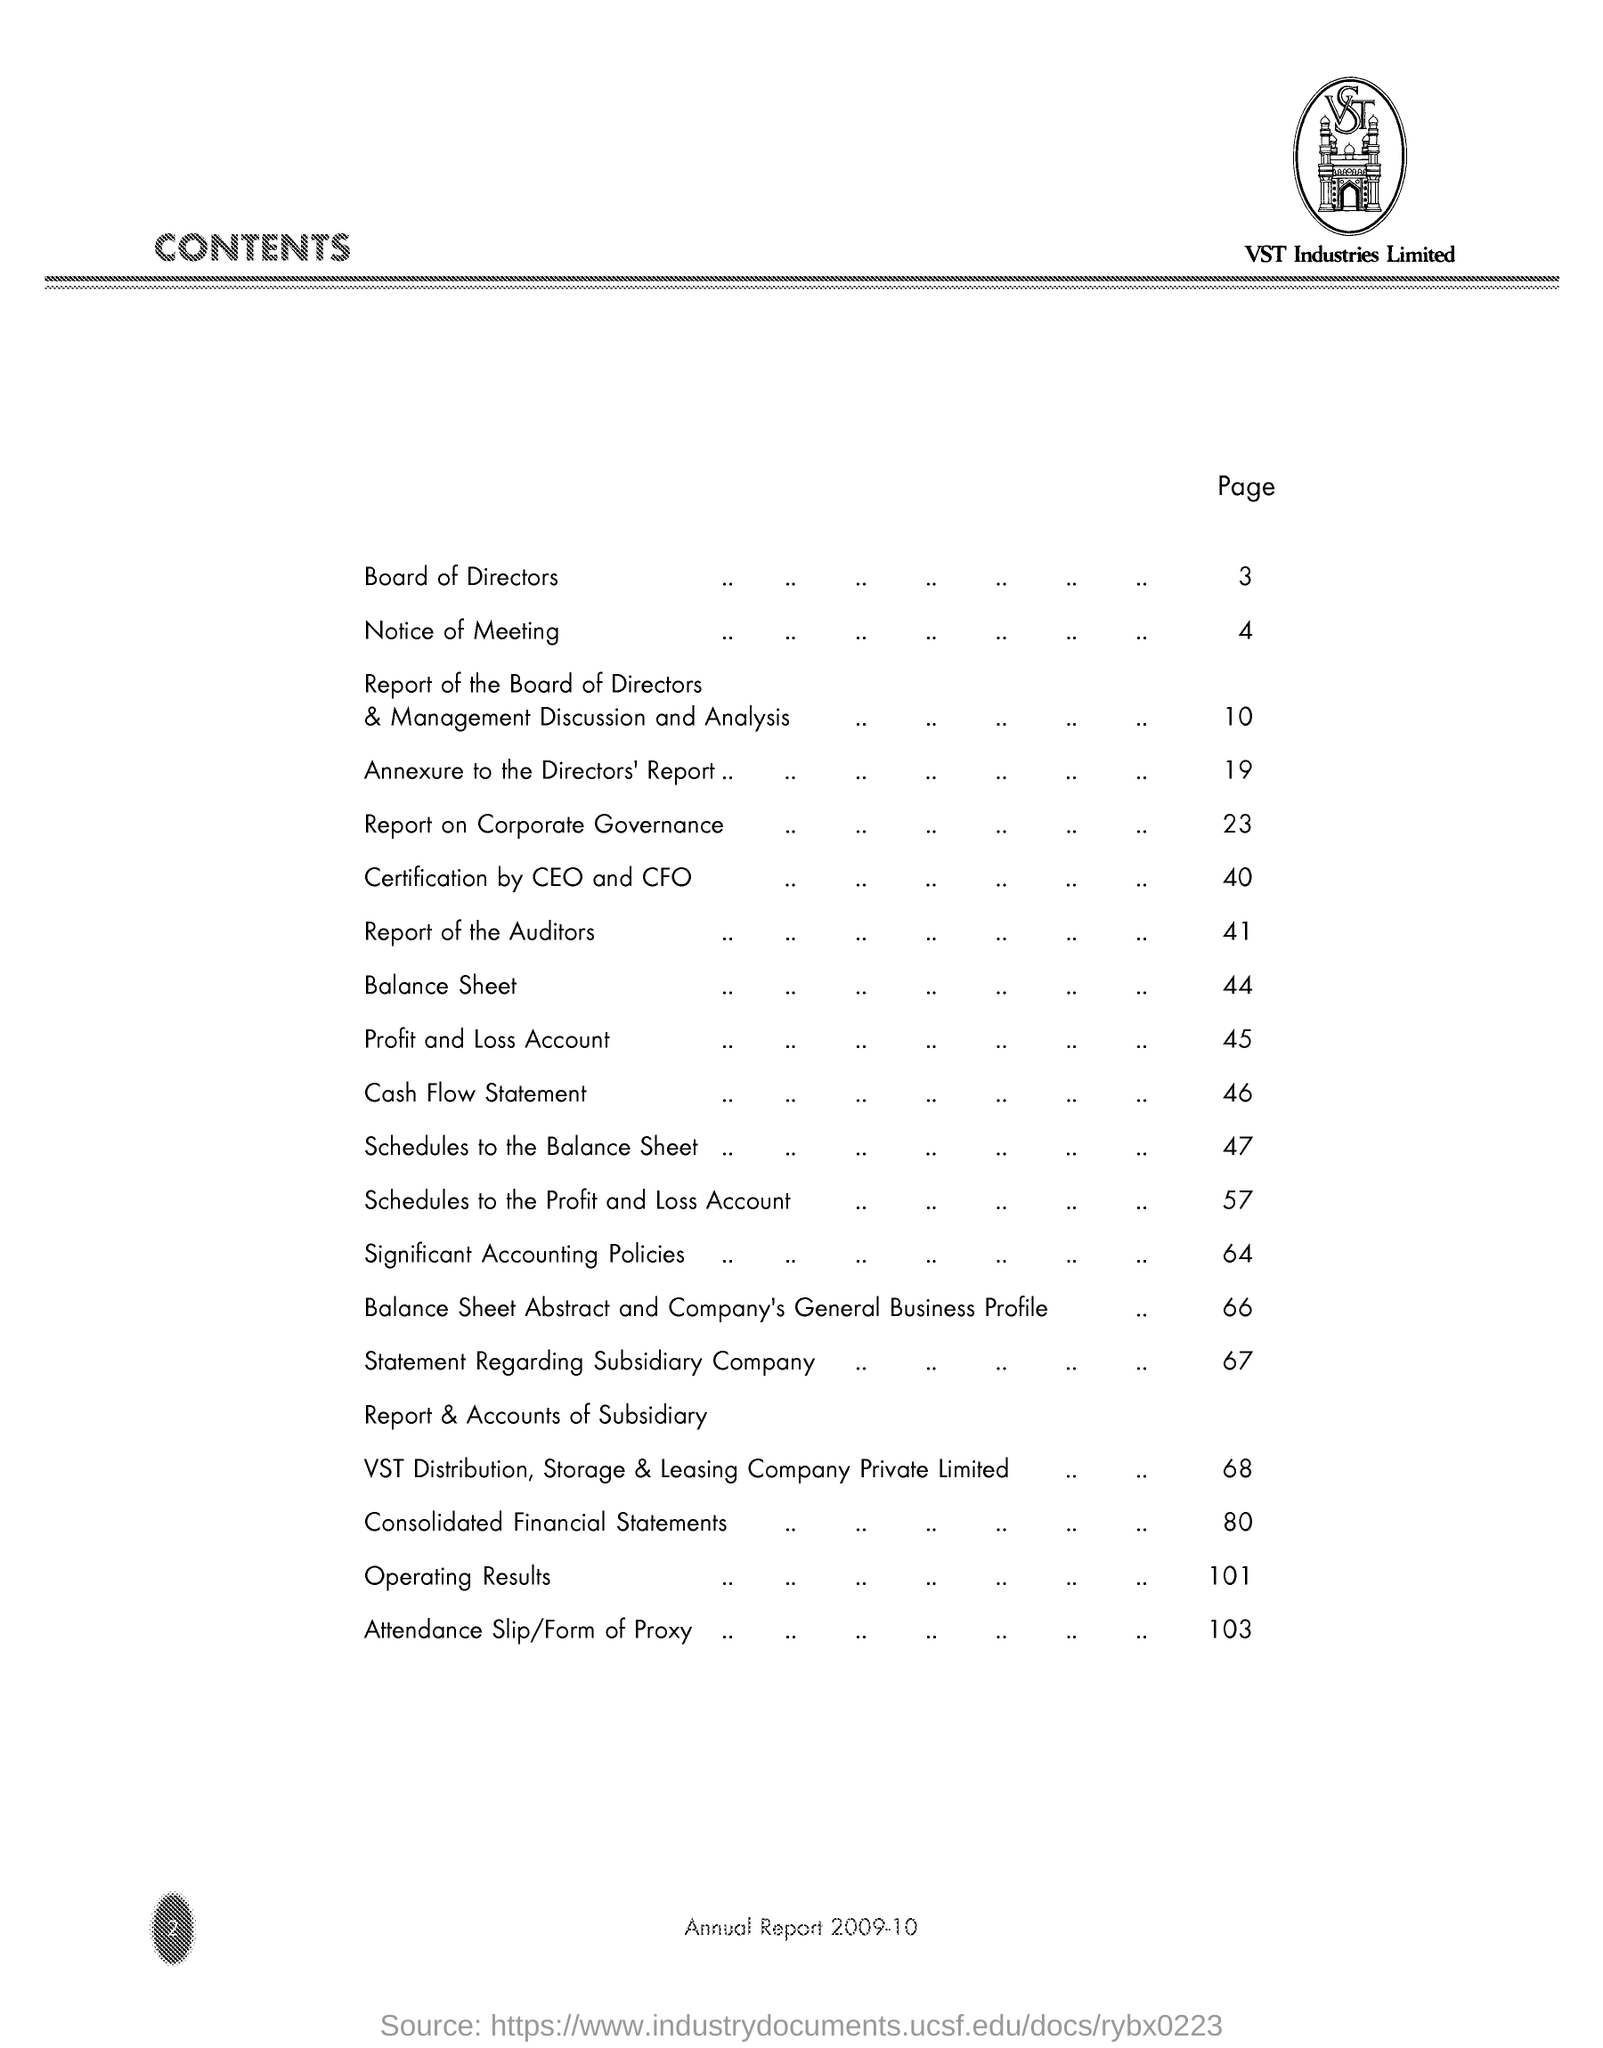What is the Company Name ?
Make the answer very short. VST Industries Limited. What is the Title of the document ?
Keep it short and to the point. CONTENTS. What is the page number for Board of Directors ?
Provide a short and direct response. 3. 